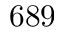Convert formula to latex. <formula><loc_0><loc_0><loc_500><loc_500>6 8 9</formula> 